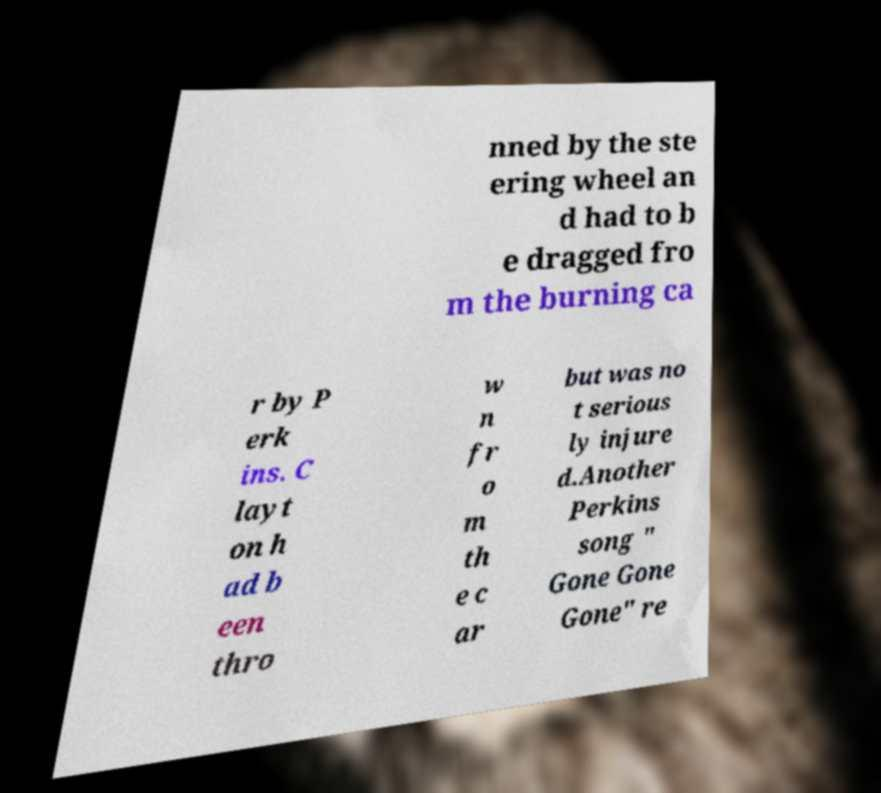Can you read and provide the text displayed in the image?This photo seems to have some interesting text. Can you extract and type it out for me? nned by the ste ering wheel an d had to b e dragged fro m the burning ca r by P erk ins. C layt on h ad b een thro w n fr o m th e c ar but was no t serious ly injure d.Another Perkins song " Gone Gone Gone" re 